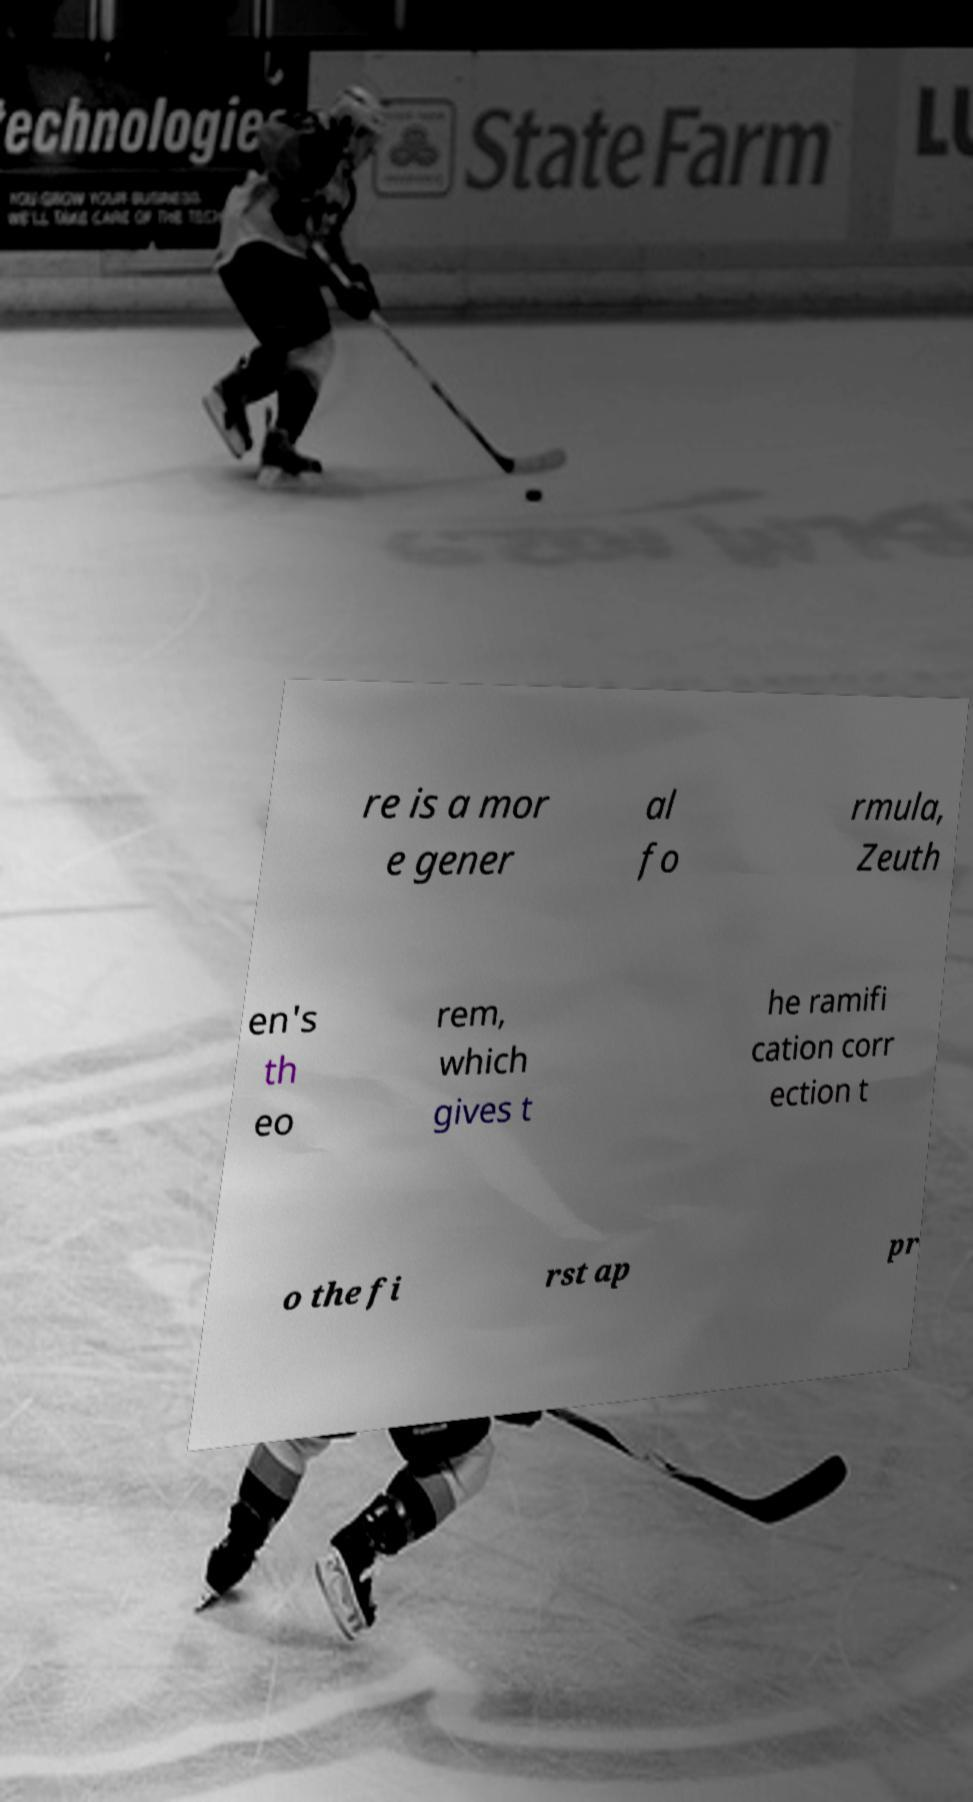Can you read and provide the text displayed in the image?This photo seems to have some interesting text. Can you extract and type it out for me? re is a mor e gener al fo rmula, Zeuth en's th eo rem, which gives t he ramifi cation corr ection t o the fi rst ap pr 